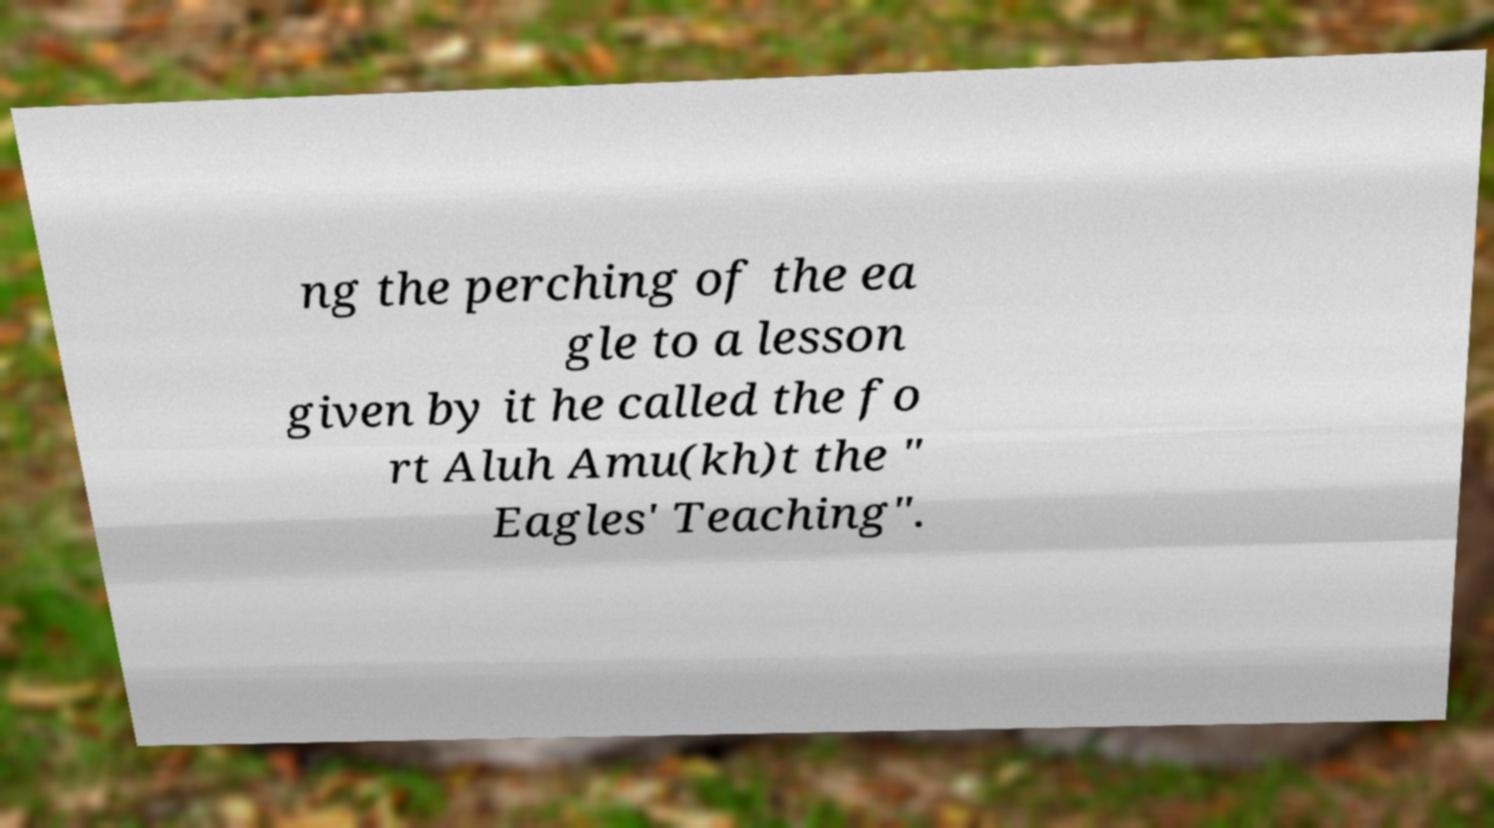Can you read and provide the text displayed in the image?This photo seems to have some interesting text. Can you extract and type it out for me? ng the perching of the ea gle to a lesson given by it he called the fo rt Aluh Amu(kh)t the " Eagles' Teaching". 